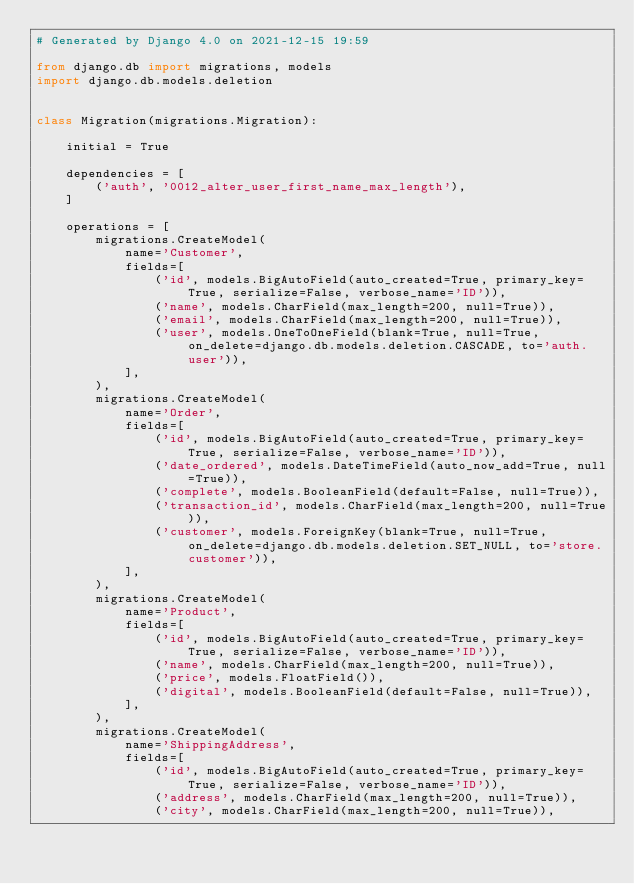<code> <loc_0><loc_0><loc_500><loc_500><_Python_># Generated by Django 4.0 on 2021-12-15 19:59

from django.db import migrations, models
import django.db.models.deletion


class Migration(migrations.Migration):

    initial = True

    dependencies = [
        ('auth', '0012_alter_user_first_name_max_length'),
    ]

    operations = [
        migrations.CreateModel(
            name='Customer',
            fields=[
                ('id', models.BigAutoField(auto_created=True, primary_key=True, serialize=False, verbose_name='ID')),
                ('name', models.CharField(max_length=200, null=True)),
                ('email', models.CharField(max_length=200, null=True)),
                ('user', models.OneToOneField(blank=True, null=True, on_delete=django.db.models.deletion.CASCADE, to='auth.user')),
            ],
        ),
        migrations.CreateModel(
            name='Order',
            fields=[
                ('id', models.BigAutoField(auto_created=True, primary_key=True, serialize=False, verbose_name='ID')),
                ('date_ordered', models.DateTimeField(auto_now_add=True, null=True)),
                ('complete', models.BooleanField(default=False, null=True)),
                ('transaction_id', models.CharField(max_length=200, null=True)),
                ('customer', models.ForeignKey(blank=True, null=True, on_delete=django.db.models.deletion.SET_NULL, to='store.customer')),
            ],
        ),
        migrations.CreateModel(
            name='Product',
            fields=[
                ('id', models.BigAutoField(auto_created=True, primary_key=True, serialize=False, verbose_name='ID')),
                ('name', models.CharField(max_length=200, null=True)),
                ('price', models.FloatField()),
                ('digital', models.BooleanField(default=False, null=True)),
            ],
        ),
        migrations.CreateModel(
            name='ShippingAddress',
            fields=[
                ('id', models.BigAutoField(auto_created=True, primary_key=True, serialize=False, verbose_name='ID')),
                ('address', models.CharField(max_length=200, null=True)),
                ('city', models.CharField(max_length=200, null=True)),</code> 